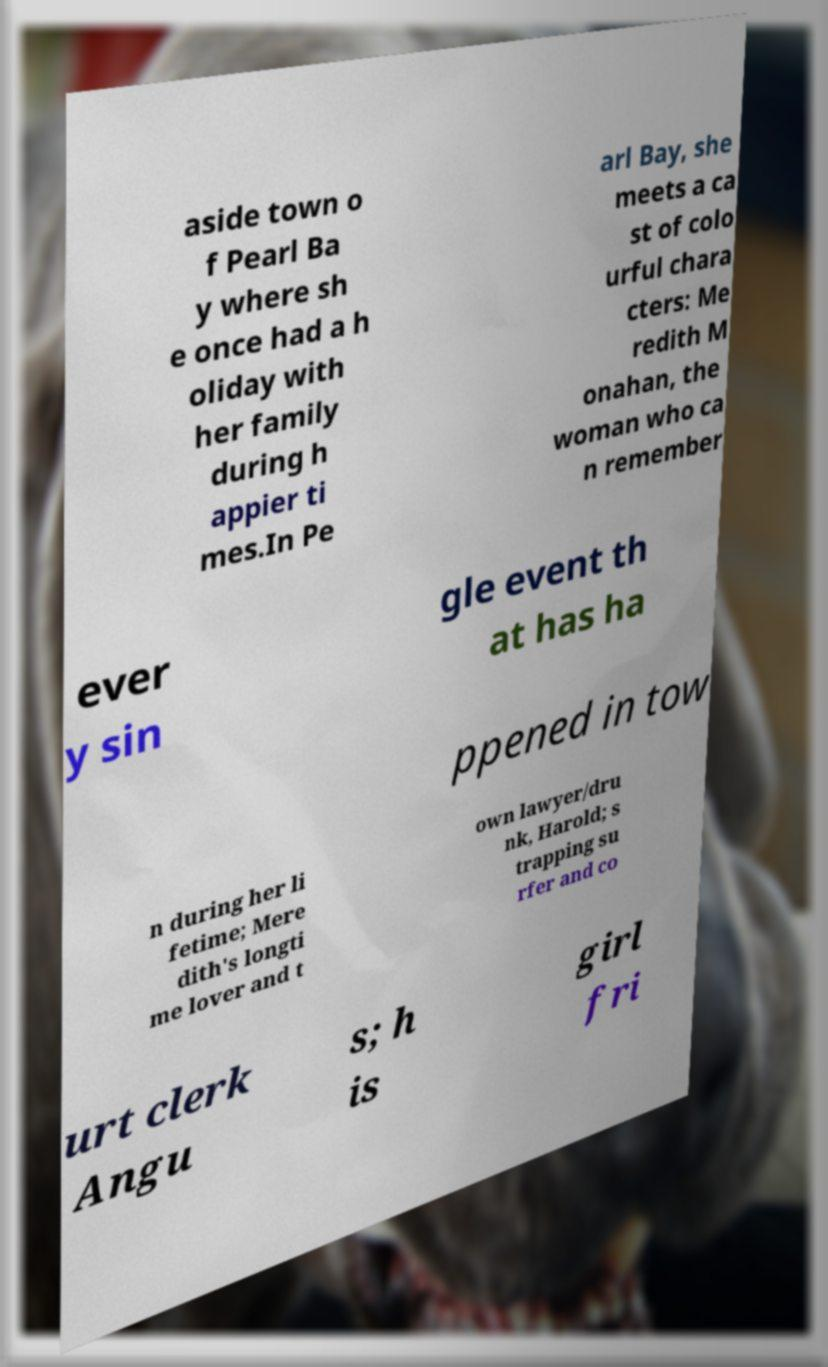There's text embedded in this image that I need extracted. Can you transcribe it verbatim? aside town o f Pearl Ba y where sh e once had a h oliday with her family during h appier ti mes.In Pe arl Bay, she meets a ca st of colo urful chara cters: Me redith M onahan, the woman who ca n remember ever y sin gle event th at has ha ppened in tow n during her li fetime; Mere dith's longti me lover and t own lawyer/dru nk, Harold; s trapping su rfer and co urt clerk Angu s; h is girl fri 